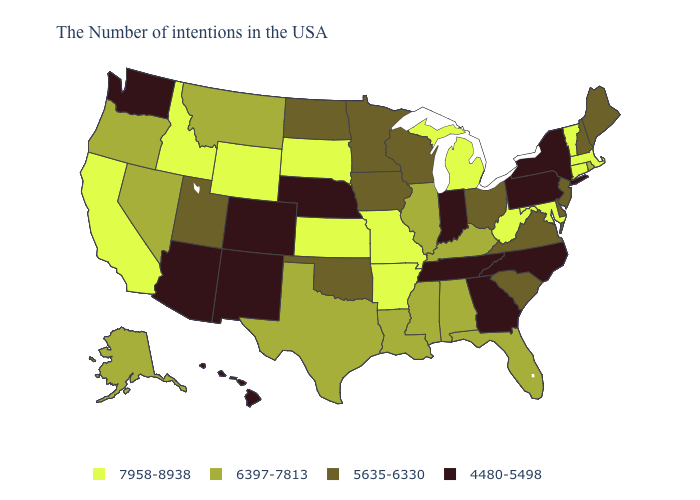Among the states that border Wisconsin , which have the highest value?
Keep it brief. Michigan. What is the value of South Dakota?
Be succinct. 7958-8938. Name the states that have a value in the range 4480-5498?
Answer briefly. New York, Pennsylvania, North Carolina, Georgia, Indiana, Tennessee, Nebraska, Colorado, New Mexico, Arizona, Washington, Hawaii. Which states have the lowest value in the South?
Answer briefly. North Carolina, Georgia, Tennessee. What is the value of Delaware?
Short answer required. 5635-6330. Does Texas have a lower value than Indiana?
Answer briefly. No. Does West Virginia have the same value as Alaska?
Write a very short answer. No. Does Michigan have the lowest value in the MidWest?
Be succinct. No. What is the value of Minnesota?
Write a very short answer. 5635-6330. What is the value of North Dakota?
Answer briefly. 5635-6330. What is the highest value in states that border Montana?
Quick response, please. 7958-8938. What is the value of Alaska?
Be succinct. 6397-7813. Does Oregon have the same value as Kentucky?
Give a very brief answer. Yes. What is the value of Louisiana?
Write a very short answer. 6397-7813. 